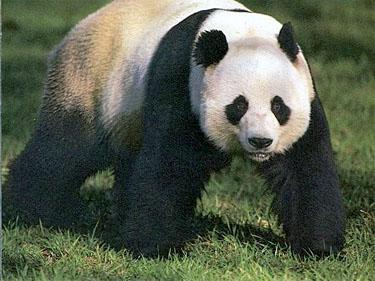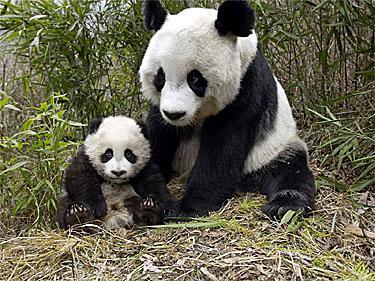The first image is the image on the left, the second image is the image on the right. Examine the images to the left and right. Is the description "There are at least two pandas in one of the images." accurate? Answer yes or no. Yes. 